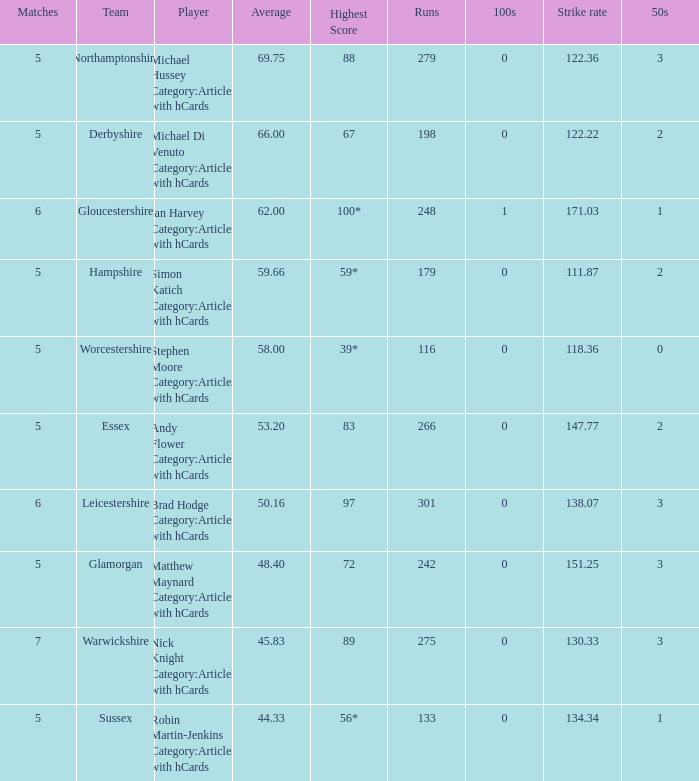What is the smallest amount of matches? 5.0. 